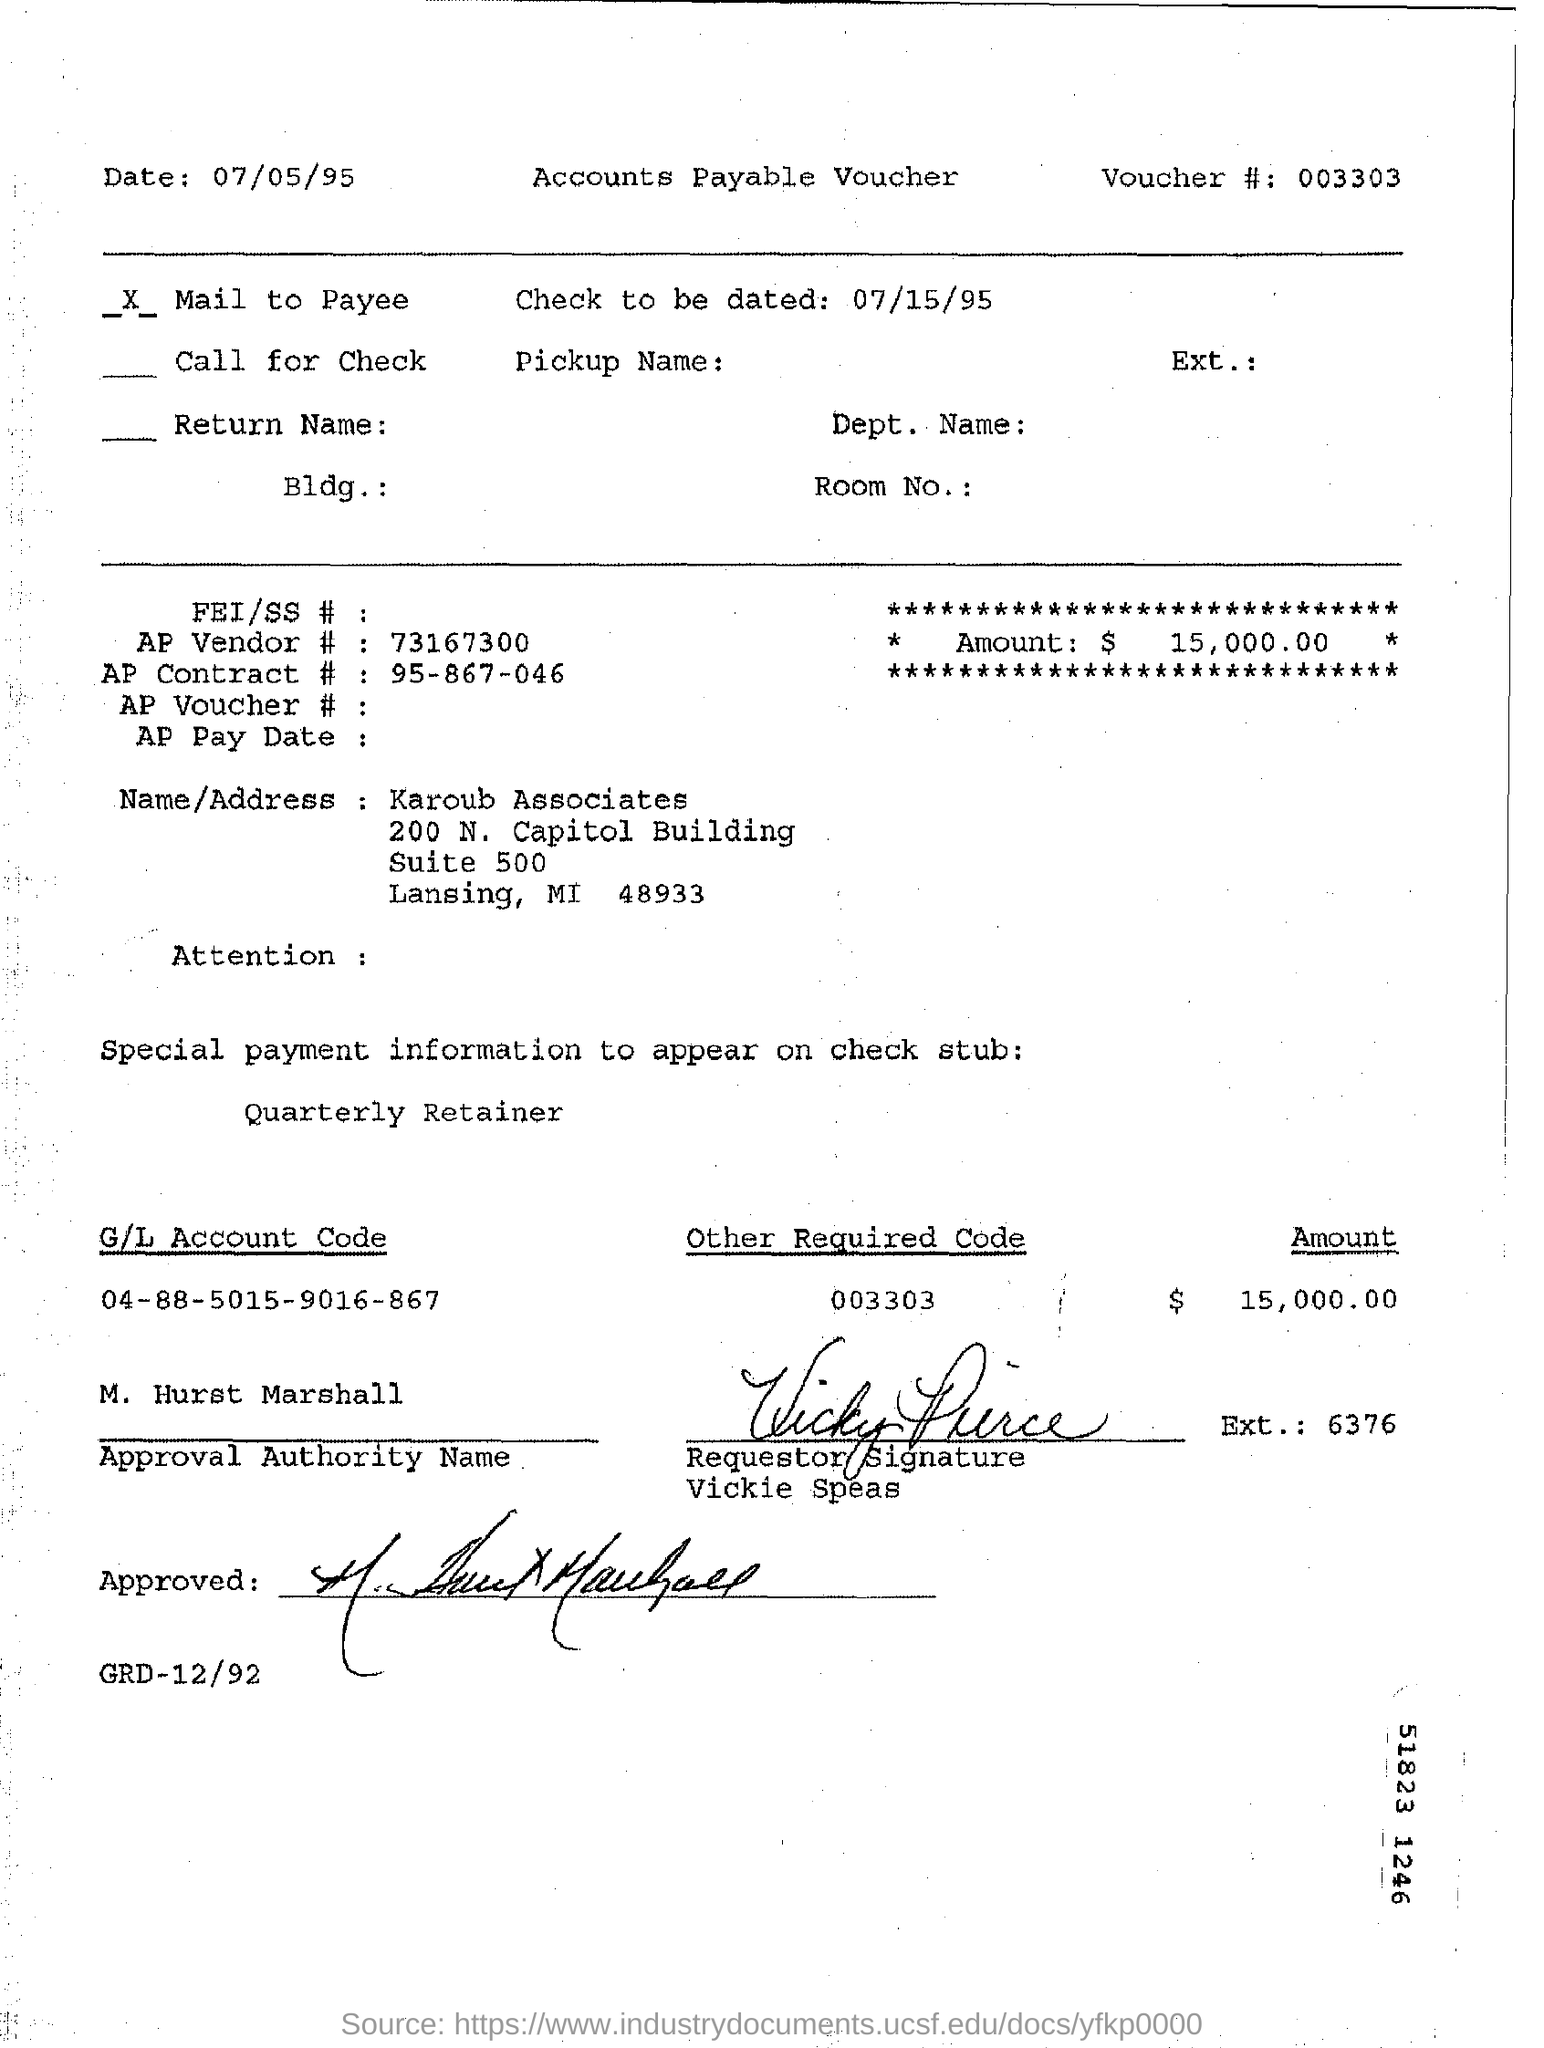What is the voucher number?
Provide a succinct answer. 003303. What is the amount payable?
Offer a terse response. $15,000.00. What is the AP vendor number?
Keep it short and to the point. 73167300. What is the G/L Account Code mentioned?
Your answer should be compact. 04-88-5015-9016-867. What is the "other required code"?
Offer a terse response. 003303. What is the extension number given next to Vickie Speas' signature?
Provide a succinct answer. 6376. Who is the approval authority?
Offer a terse response. M. Hurst Marshall. 